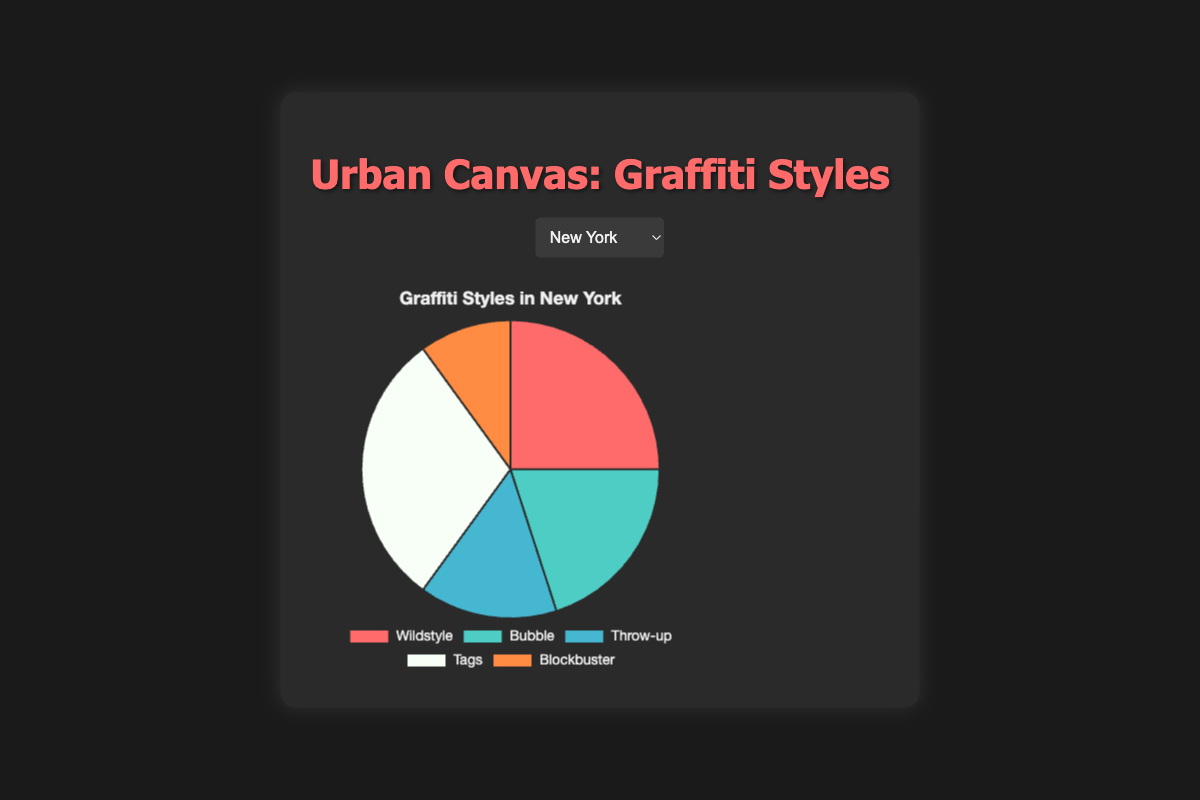Which city has the highest proportion of Wildstyle graffiti? By comparing the proportion of Wildstyle graffiti in each city's pie chart, we see that São Paulo has the highest at 35%.
Answer: São Paulo Which two styles combined make up the majority of graffiti in New York? In New York, Tags (30%) and Wildstyle (25%) combined make up 55%, which is more than half.
Answer: Tags and Wildstyle How does the proportion of Tags in Berlin compare to that in London? The chart shows that Tags represent 30% of Berlin’s graffiti and 25% in London. Thus, Tags are more prevalent in Berlin.
Answer: Berlin has more What is the smallest category of graffiti style in Los Angeles? By observing the pie chart for Los Angeles, Throw-up graffiti occupies the smallest section, representing 10% of the graffiti.
Answer: Throw-up What proportion of Bubble graffiti is present in London? The London pie chart indicates that Bubble graffiti accounts for 20% of the total graffiti styles.
Answer: 20% In which city is the proportion of Blockbuster graffiti the same? By comparing the pie charts, it is evident that Blockbuster graffiti is consistently at 10% in all cities.
Answer: All cities What's the combined total of Wildstyle and Throw-up styles in São Paulo? In São Paulo, Wildstyle makes up 35% and Throw-up 10%. Adding these, 35 + 10 = 45%.
Answer: 45% Does Berlin or New York have a higher diversity in graffiti styles, based on the spread of proportions? Berlin has a more even distribution across styles (20%, 15%, 25%, 30%, 10%) compared to New York where Tags dominate at 30%. Hence, Berlin has higher diversity.
Answer: Berlin Which city has the largest proportion of Throw-up graffiti? Examining the charts, London has the highest proportion of Throw-up graffiti at 30%.
Answer: London 